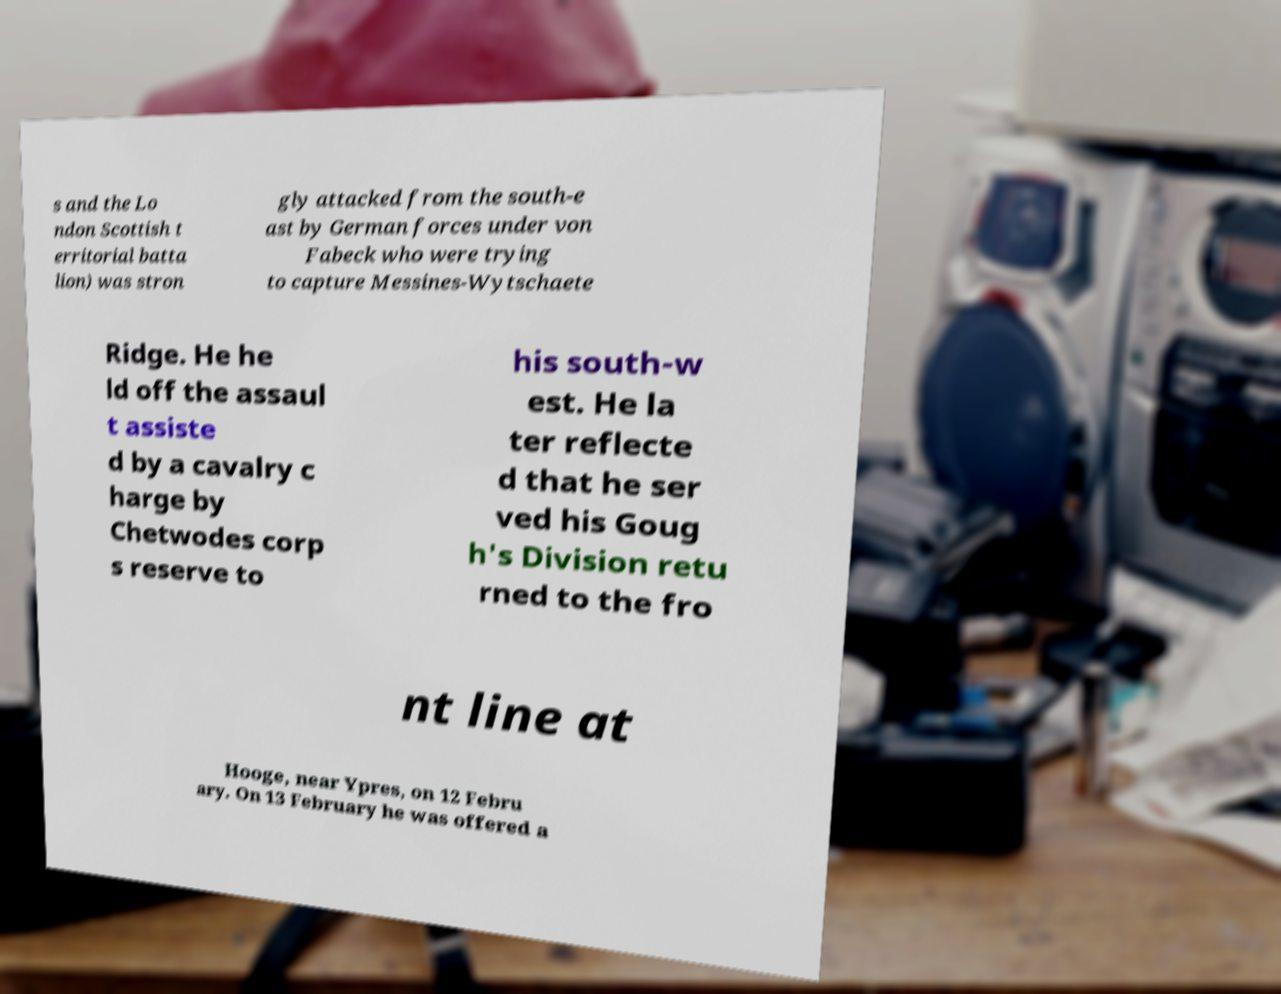Please read and relay the text visible in this image. What does it say? s and the Lo ndon Scottish t erritorial batta lion) was stron gly attacked from the south-e ast by German forces under von Fabeck who were trying to capture Messines-Wytschaete Ridge. He he ld off the assaul t assiste d by a cavalry c harge by Chetwodes corp s reserve to his south-w est. He la ter reflecte d that he ser ved his Goug h's Division retu rned to the fro nt line at Hooge, near Ypres, on 12 Febru ary. On 13 February he was offered a 